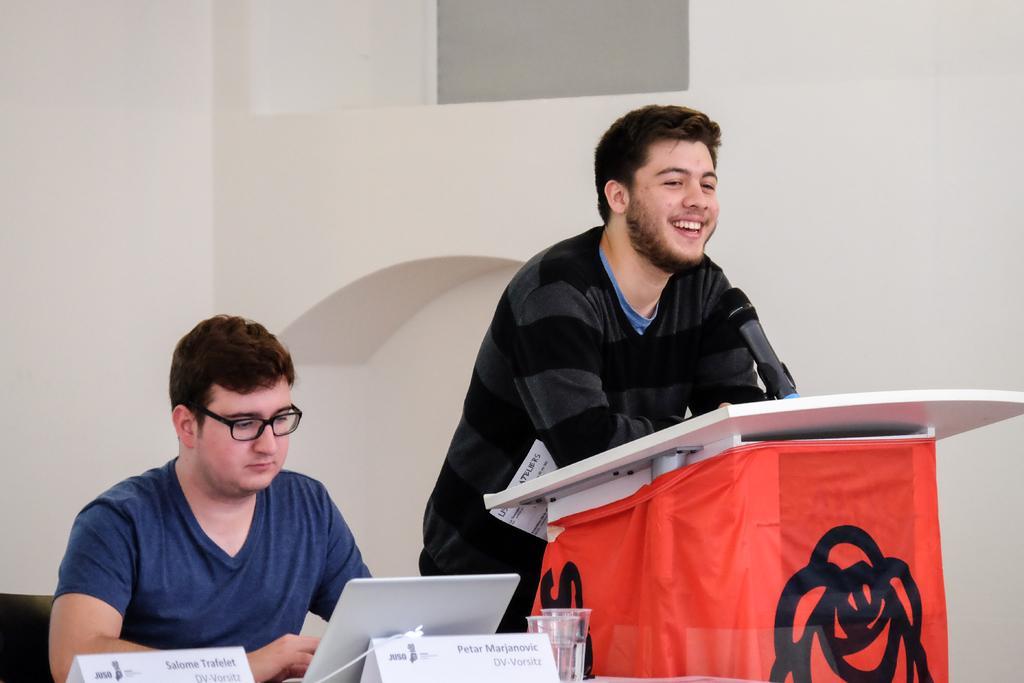How would you summarize this image in a sentence or two? In this image we can see two persons, microphone, podium, name boards, glasses and other objects. In the background of the image there is a wall and an object. 